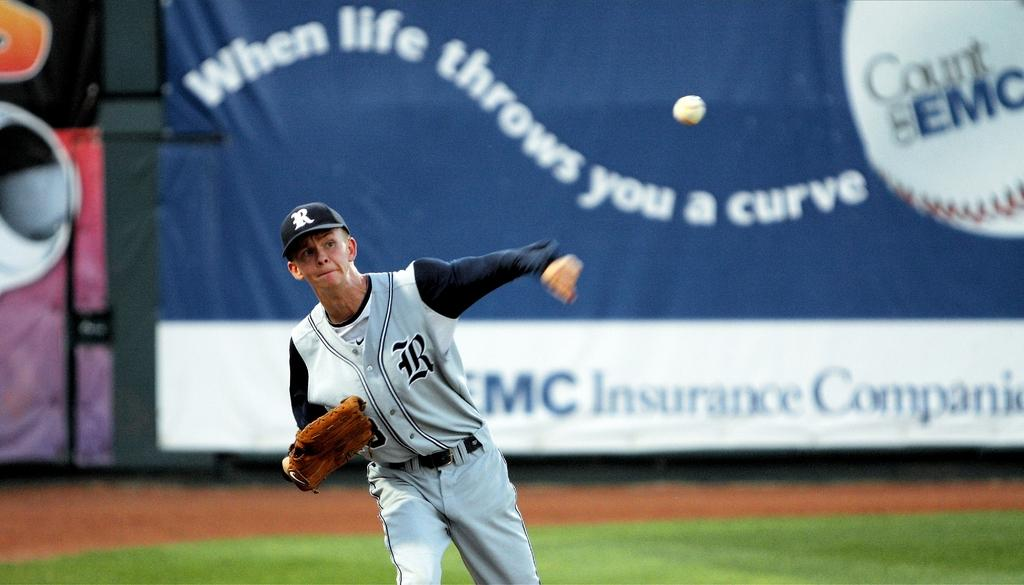<image>
Offer a succinct explanation of the picture presented. a baseball player that had the letter B on his jersey 